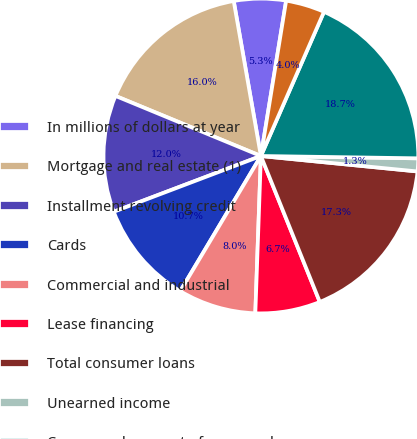Convert chart to OTSL. <chart><loc_0><loc_0><loc_500><loc_500><pie_chart><fcel>In millions of dollars at year<fcel>Mortgage and real estate (1)<fcel>Installment revolving credit<fcel>Cards<fcel>Commercial and industrial<fcel>Lease financing<fcel>Total consumer loans<fcel>Unearned income<fcel>Consumer loans net of unearned<fcel>Loans to financial<nl><fcel>5.33%<fcel>16.0%<fcel>12.0%<fcel>10.67%<fcel>8.0%<fcel>6.67%<fcel>17.33%<fcel>1.33%<fcel>18.67%<fcel>4.0%<nl></chart> 